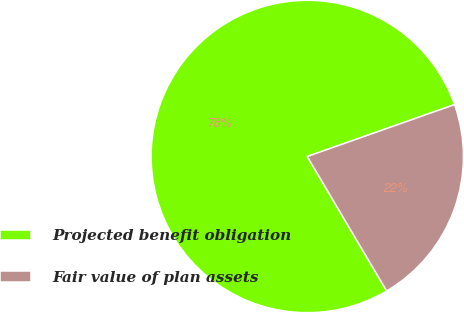<chart> <loc_0><loc_0><loc_500><loc_500><pie_chart><fcel>Projected benefit obligation<fcel>Fair value of plan assets<nl><fcel>78.1%<fcel>21.9%<nl></chart> 